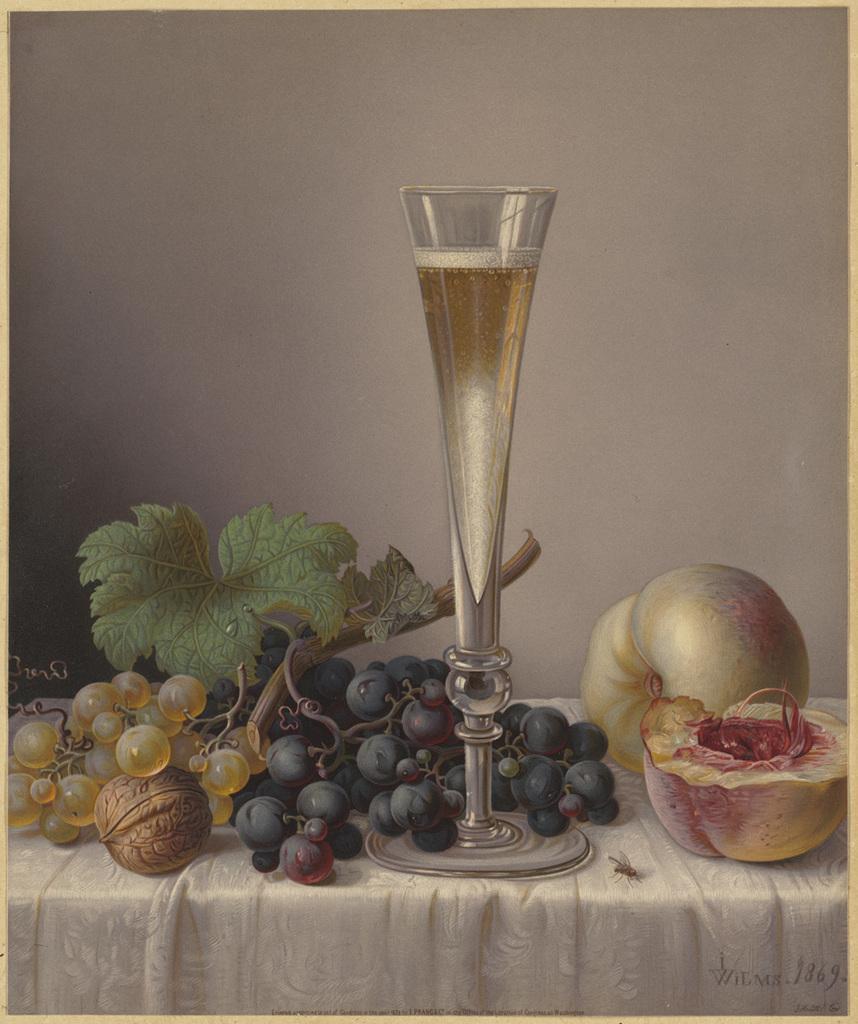Describe this image in one or two sentences. In the foreground I can see a bunch of grapes, walnut, pumpkin fruits and a glass on the table. In the background I can see a wall. This image looks like a photo frame. 